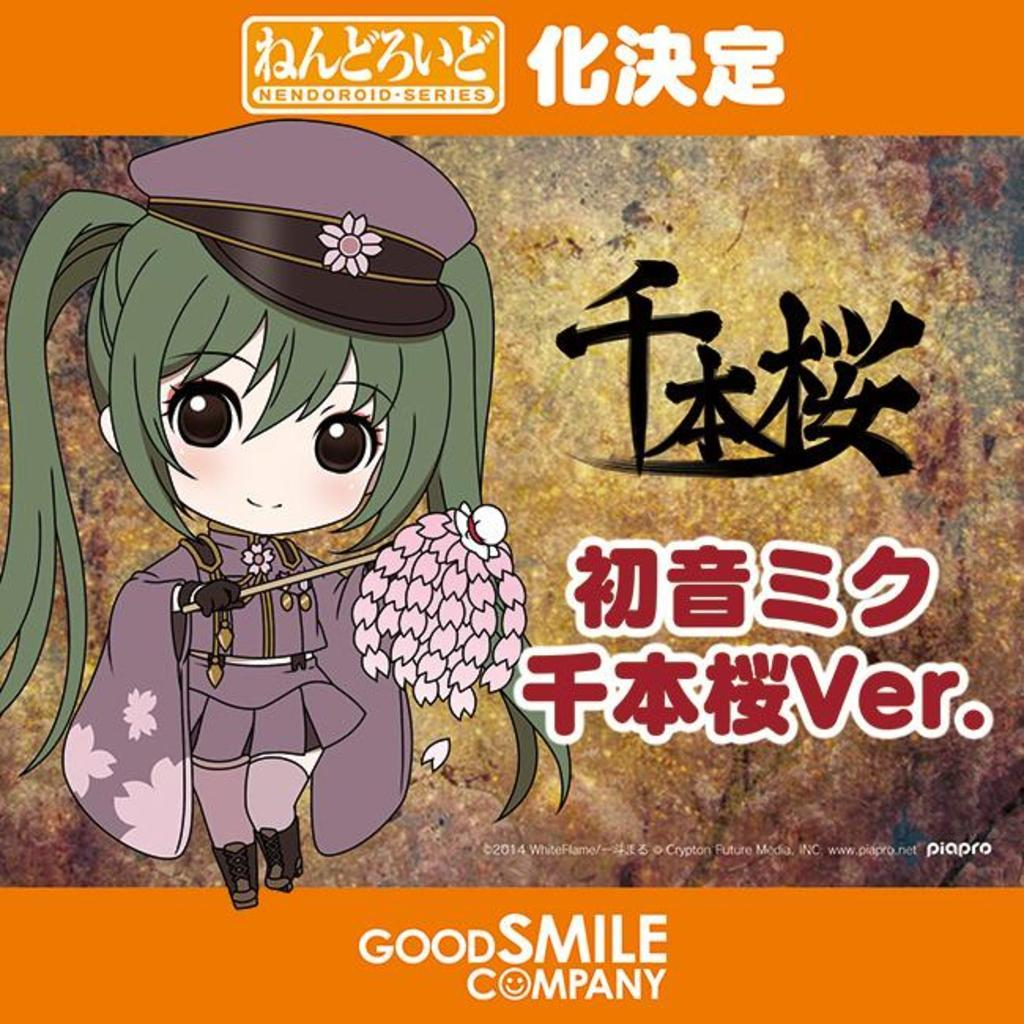What is the main subject of the poster in the image? The main subject of the poster in the image is a girl. What is the girl wearing? The girl is wearing clothes, shoes, and a cap. What is the girl holding in the image? The girl is holding a stick. Is there any text on the poster? Yes, there is text on the poster. How many bottles can be seen in the image? There are no bottles present in the image. Is there a deer visible in the image? There is no deer present in the image. 